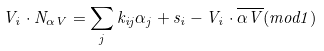Convert formula to latex. <formula><loc_0><loc_0><loc_500><loc_500>V _ { i } \cdot N _ { \alpha V } = \sum _ { j } k _ { i j } \alpha _ { j } + s _ { i } - V _ { i } \cdot \overline { \alpha V } ( m o d 1 )</formula> 